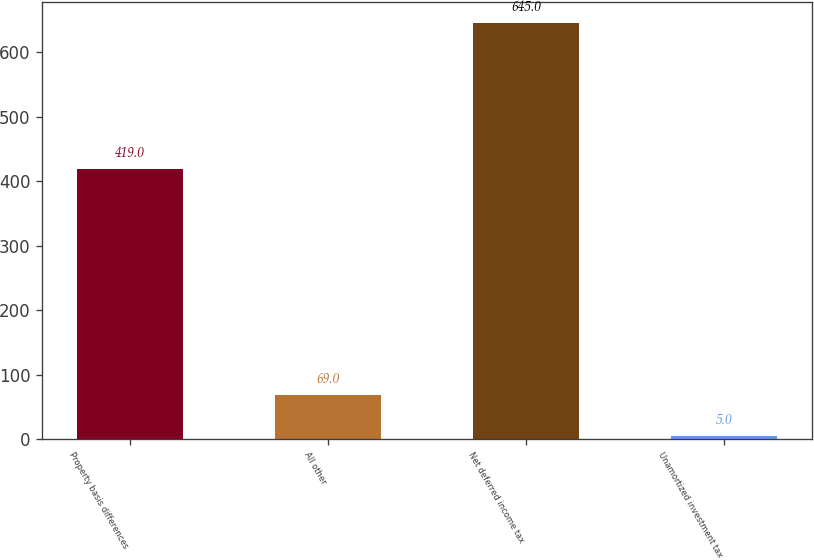<chart> <loc_0><loc_0><loc_500><loc_500><bar_chart><fcel>Property basis differences<fcel>All other<fcel>Net deferred income tax<fcel>Unamortized investment tax<nl><fcel>419<fcel>69<fcel>645<fcel>5<nl></chart> 